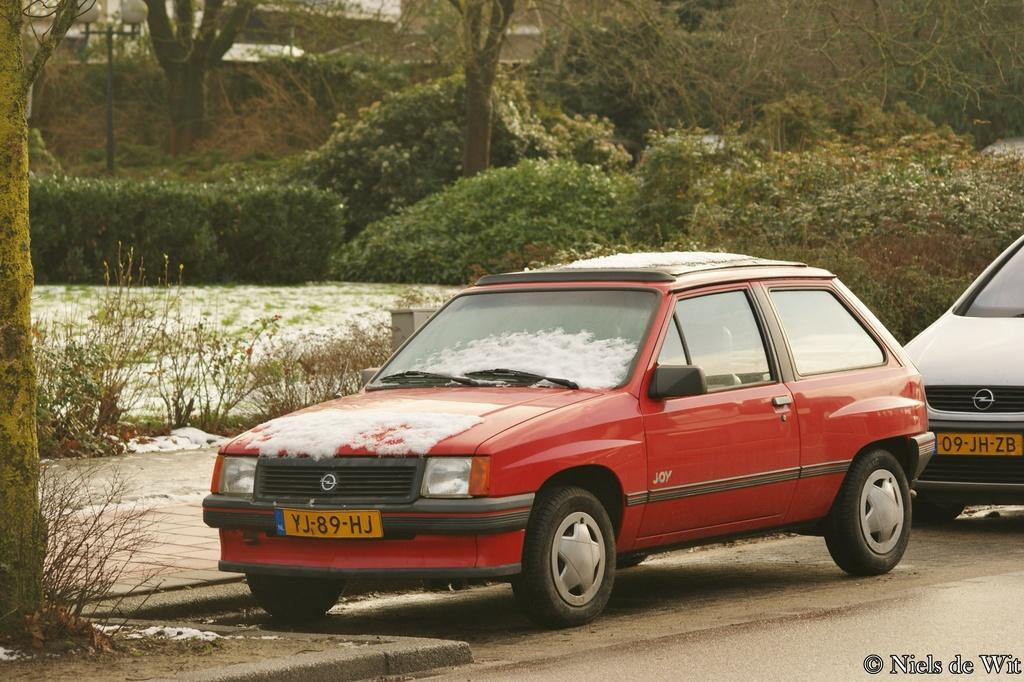Provide a one-sentence caption for the provided image. A red car with the license plate number YJ-89-HJ. 